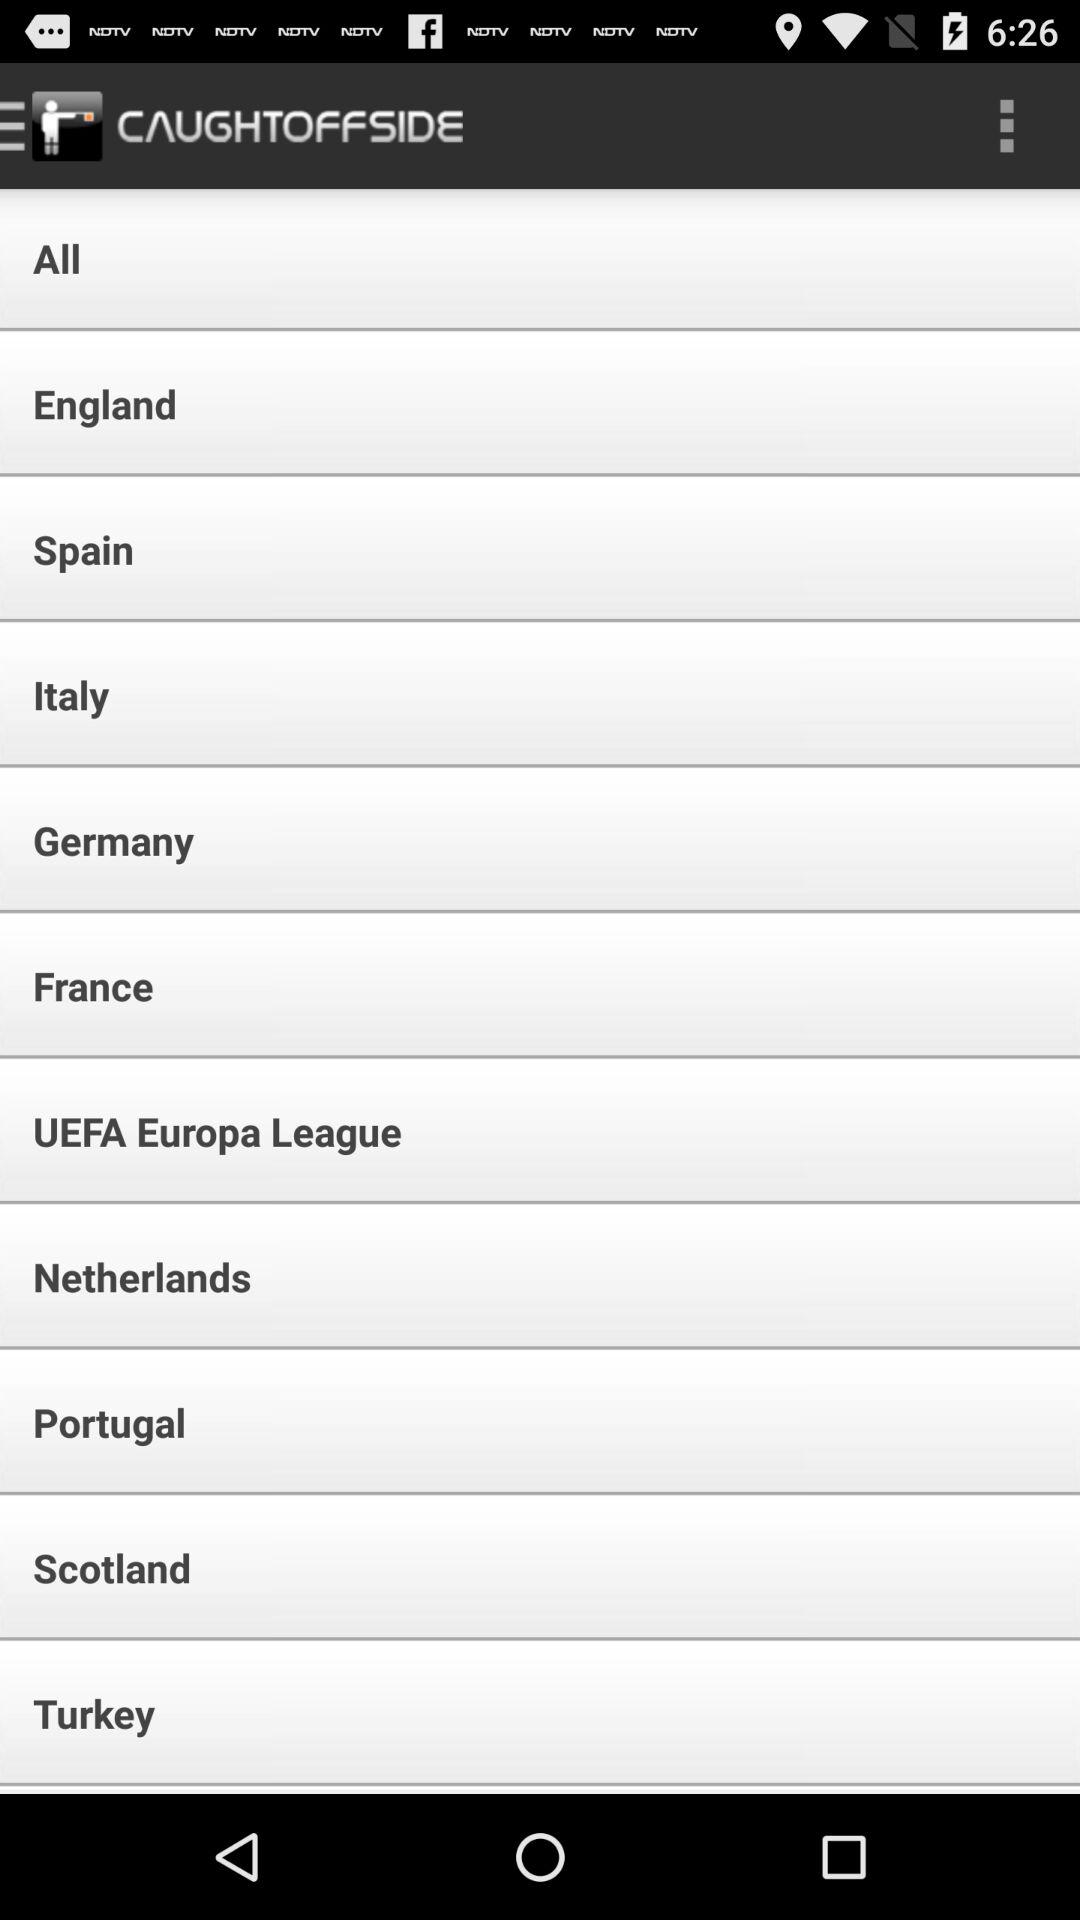What is the name of the application? The name of the application is "CAUGHTOFFSIDE". 